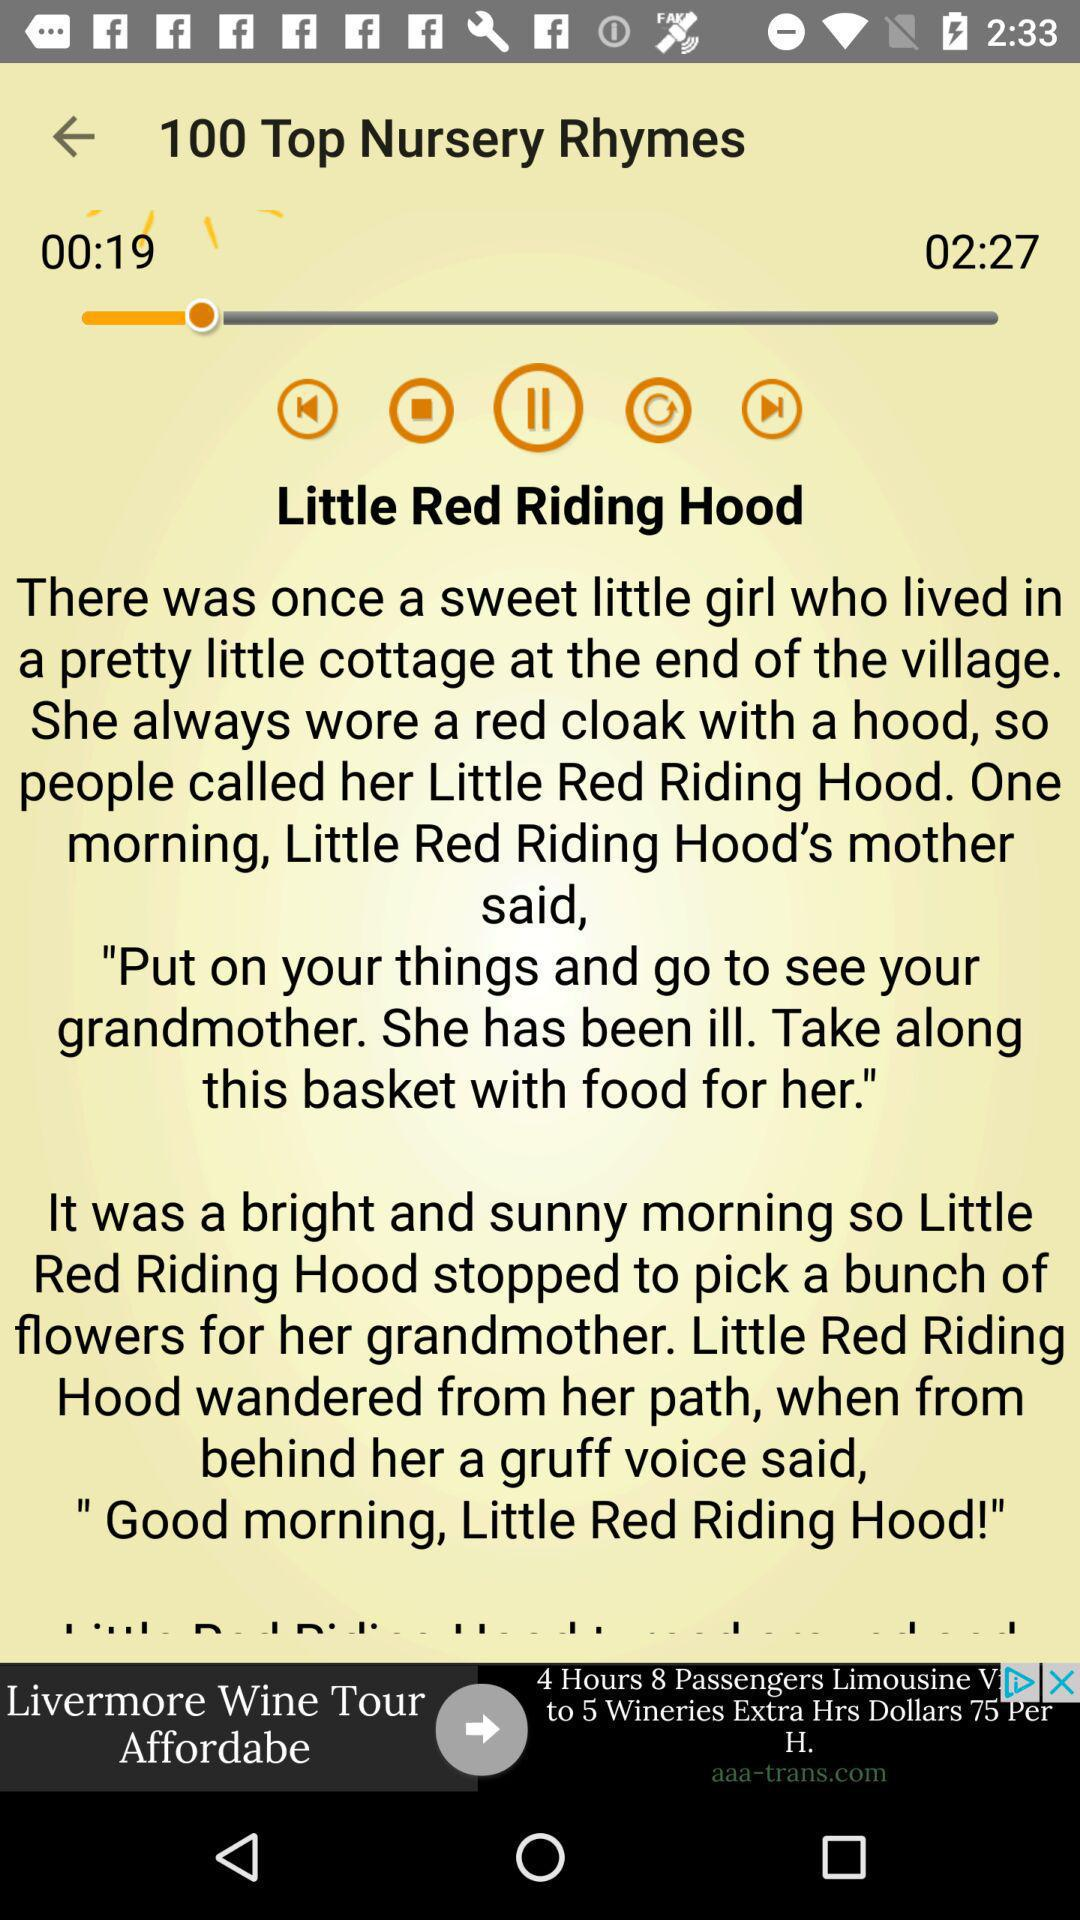Who wrote "Little Red Riding Hood"?
When the provided information is insufficient, respond with <no answer>. <no answer> 